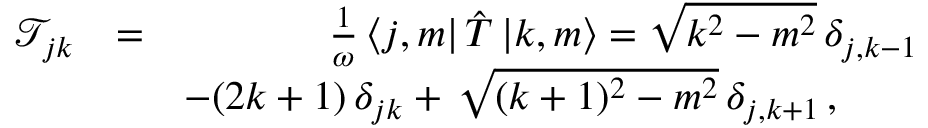Convert formula to latex. <formula><loc_0><loc_0><loc_500><loc_500>\begin{array} { r l r } { \mathcal { T } _ { j k } } & { = } & { \frac { 1 } { \omega } \, \langle j , m | \, { \hat { T } } \, { | k , m \rangle } = \sqrt { k ^ { 2 } - m ^ { 2 } } \, \delta _ { j , k - 1 } } \\ & { - ( 2 k + 1 ) \, \delta _ { j k } + \, \sqrt { ( k + 1 ) ^ { 2 } - m ^ { 2 } } \, \delta _ { j , k + 1 } \, , \quad } \end{array}</formula> 